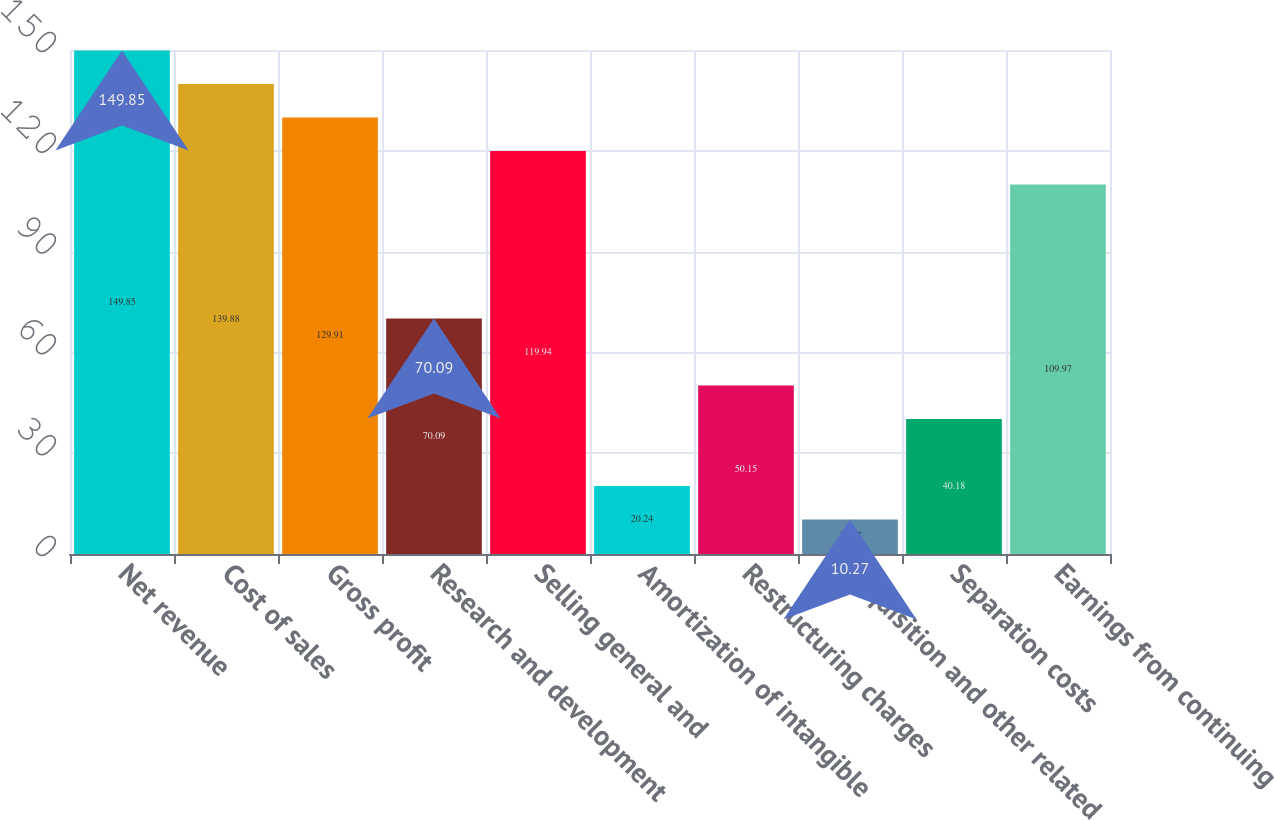Convert chart to OTSL. <chart><loc_0><loc_0><loc_500><loc_500><bar_chart><fcel>Net revenue<fcel>Cost of sales<fcel>Gross profit<fcel>Research and development<fcel>Selling general and<fcel>Amortization of intangible<fcel>Restructuring charges<fcel>Acquisition and other related<fcel>Separation costs<fcel>Earnings from continuing<nl><fcel>149.85<fcel>139.88<fcel>129.91<fcel>70.09<fcel>119.94<fcel>20.24<fcel>50.15<fcel>10.27<fcel>40.18<fcel>109.97<nl></chart> 